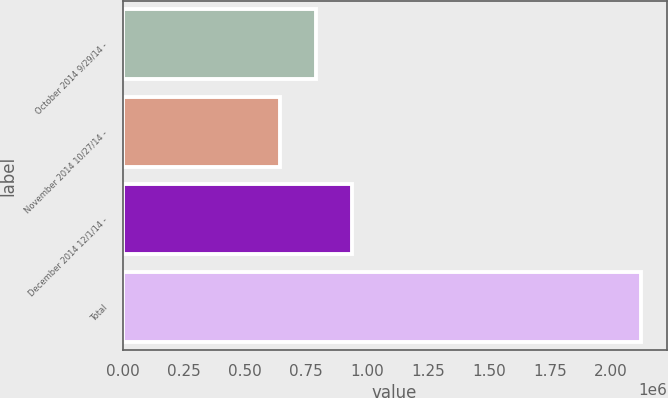Convert chart to OTSL. <chart><loc_0><loc_0><loc_500><loc_500><bar_chart><fcel>October 2014 9/29/14 -<fcel>November 2014 10/27/14 -<fcel>December 2014 12/1/14 -<fcel>Total<nl><fcel>792441<fcel>644735<fcel>940148<fcel>2.1218e+06<nl></chart> 